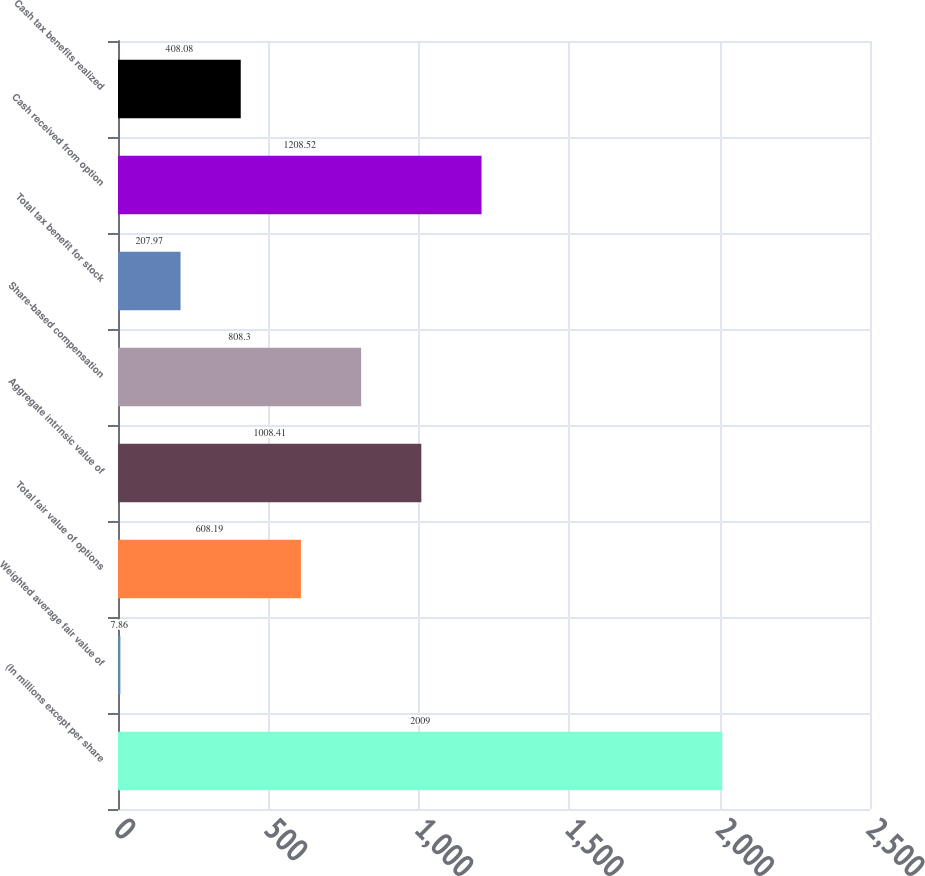Convert chart to OTSL. <chart><loc_0><loc_0><loc_500><loc_500><bar_chart><fcel>(In millions except per share<fcel>Weighted average fair value of<fcel>Total fair value of options<fcel>Aggregate intrinsic value of<fcel>Share-based compensation<fcel>Total tax benefit for stock<fcel>Cash received from option<fcel>Cash tax benefits realized<nl><fcel>2009<fcel>7.86<fcel>608.19<fcel>1008.41<fcel>808.3<fcel>207.97<fcel>1208.52<fcel>408.08<nl></chart> 